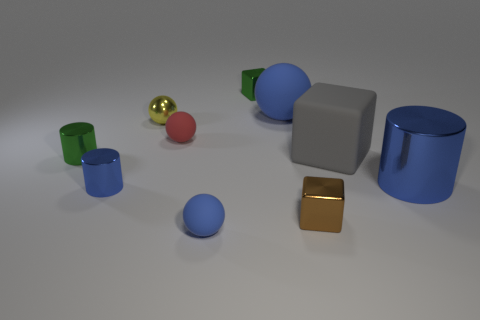Subtract all small brown metal cubes. How many cubes are left? 2 Subtract all red cylinders. How many blue balls are left? 2 Subtract 1 blocks. How many blocks are left? 2 Subtract all green cylinders. How many cylinders are left? 2 Subtract all balls. How many objects are left? 6 Subtract all cyan cylinders. Subtract all purple spheres. How many cylinders are left? 3 Add 9 gray rubber cubes. How many gray rubber cubes are left? 10 Add 10 big brown matte cylinders. How many big brown matte cylinders exist? 10 Subtract 0 cyan cylinders. How many objects are left? 10 Subtract all large brown rubber blocks. Subtract all large blue cylinders. How many objects are left? 9 